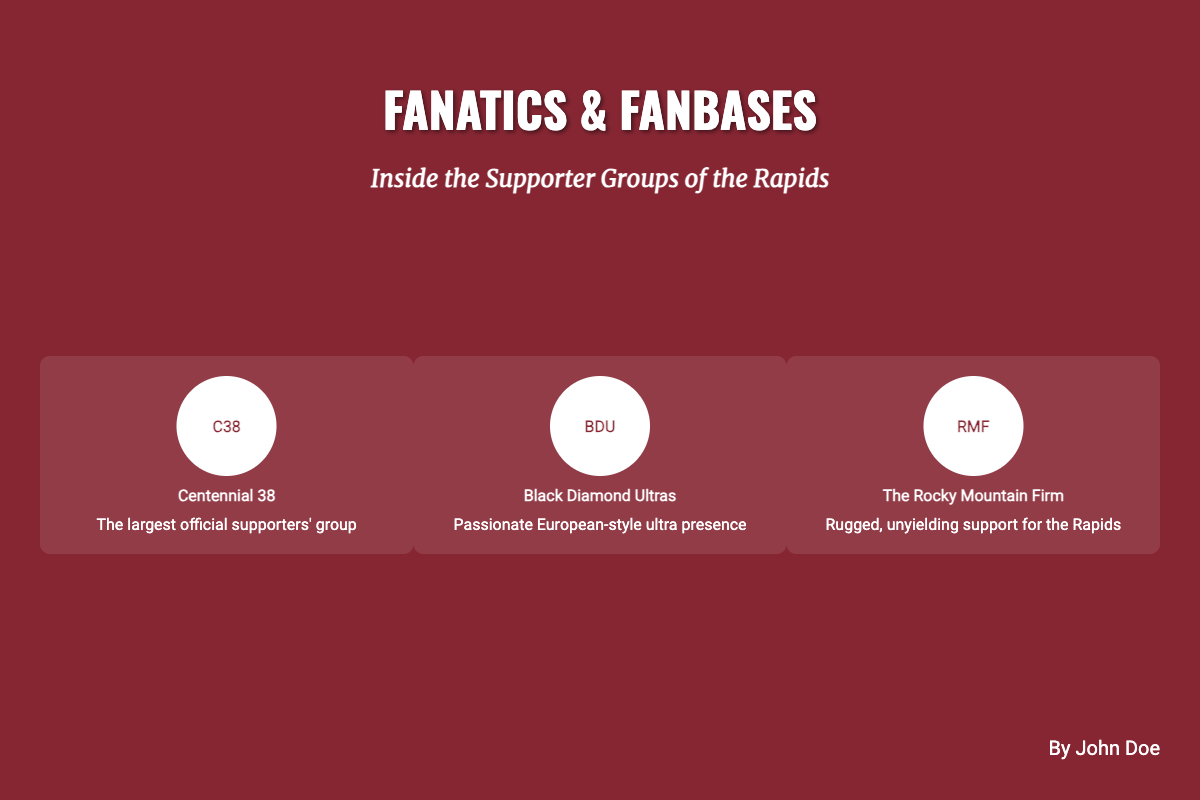What is the title of the book? The title of the book is prominently displayed at the top of the cover.
Answer: Fanatics & Fanbases Who is the author of the book? The author's name is located at the bottom right of the cover.
Answer: John Doe What is the subtitle of the book? The subtitle is directly below the title and provides more context.
Answer: Inside the Supporter Groups of the Rapids Which supporter group is identified as the largest official supporters' group? The cover lists supporter groups with descriptions; the largest is identified.
Answer: Centennial 38 What logo represents the Black Diamond Ultras? The logo for each group is displayed alongside names; it's indicated with initials.
Answer: BDU How many supporter groups are highlighted on the cover? The cover features a specific number of supporter groups in the visuals.
Answer: Three What color is the background of the book cover? The color scheme of the cover is described in the design details.
Answer: Burgundy Which supporter group is noted for its "passionate European-style ultra presence"? The descriptions alongside each group provide insights into their characteristics.
Answer: Black Diamond Ultras What is the shape of the group logo on the cover? The design of the group logos is detailed in the cover description.
Answer: Circle 